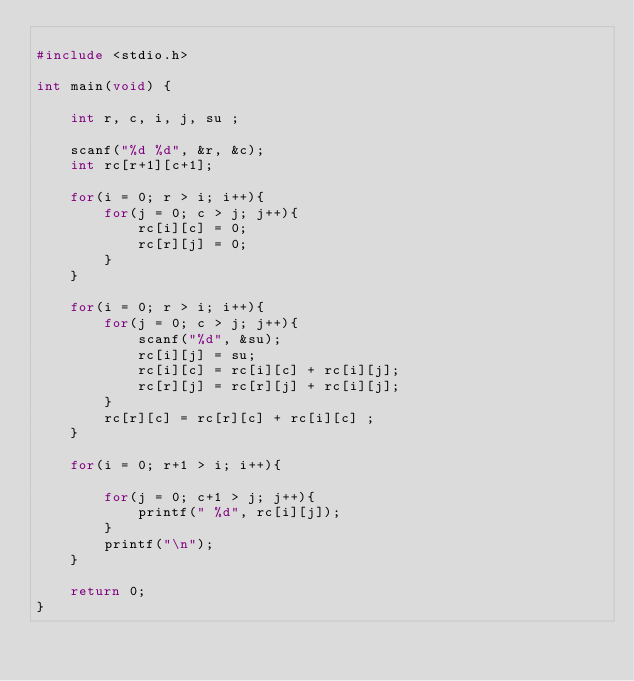Convert code to text. <code><loc_0><loc_0><loc_500><loc_500><_C_>
#include <stdio.h>

int main(void) {

	int r, c, i, j, su ;

	scanf("%d %d", &r, &c);
	int rc[r+1][c+1];
	
	for(i = 0; r > i; i++){
		for(j = 0; c > j; j++){
			rc[i][c] = 0;
			rc[r][j] = 0;
		}
	}
	
	for(i = 0; r > i; i++){
		for(j = 0; c > j; j++){
			scanf("%d", &su);
			rc[i][j] = su;
			rc[i][c] = rc[i][c] + rc[i][j];
			rc[r][j] = rc[r][j] + rc[i][j];
		}
		rc[r][c] = rc[r][c] + rc[i][c] ;
	}
	
	for(i = 0; r+1 > i; i++){

		for(j = 0; c+1 > j; j++){
			printf(" %d", rc[i][j]);
		}
		printf("\n");
	}

	return 0;
}</code> 